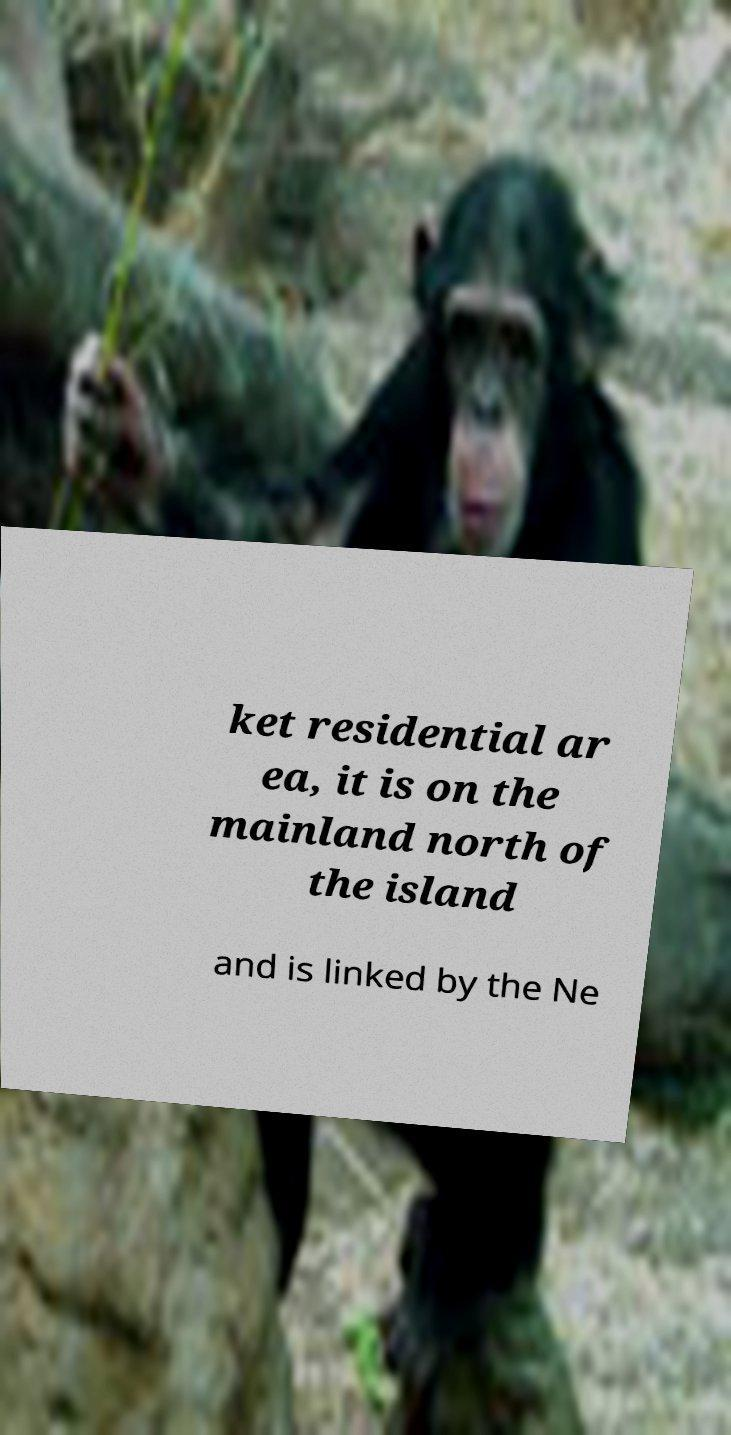Could you extract and type out the text from this image? ket residential ar ea, it is on the mainland north of the island and is linked by the Ne 